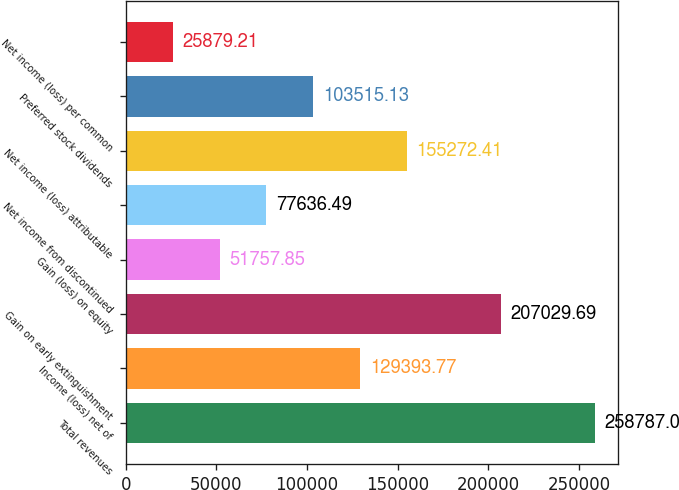<chart> <loc_0><loc_0><loc_500><loc_500><bar_chart><fcel>Total revenues<fcel>Income (loss) net of<fcel>Gain on early extinguishment<fcel>Gain (loss) on equity<fcel>Net income from discontinued<fcel>Net income (loss) attributable<fcel>Preferred stock dividends<fcel>Net income (loss) per common<nl><fcel>258787<fcel>129394<fcel>207030<fcel>51757.8<fcel>77636.5<fcel>155272<fcel>103515<fcel>25879.2<nl></chart> 